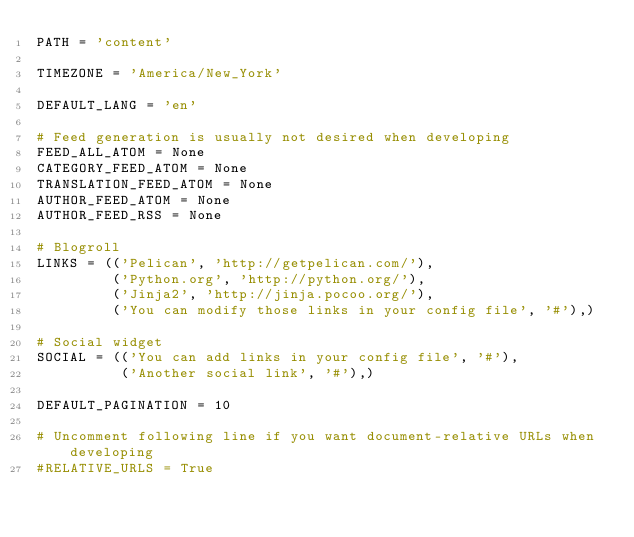Convert code to text. <code><loc_0><loc_0><loc_500><loc_500><_Python_>PATH = 'content'

TIMEZONE = 'America/New_York'

DEFAULT_LANG = 'en'

# Feed generation is usually not desired when developing
FEED_ALL_ATOM = None
CATEGORY_FEED_ATOM = None
TRANSLATION_FEED_ATOM = None
AUTHOR_FEED_ATOM = None
AUTHOR_FEED_RSS = None

# Blogroll
LINKS = (('Pelican', 'http://getpelican.com/'),
         ('Python.org', 'http://python.org/'),
         ('Jinja2', 'http://jinja.pocoo.org/'),
         ('You can modify those links in your config file', '#'),)

# Social widget
SOCIAL = (('You can add links in your config file', '#'),
          ('Another social link', '#'),)

DEFAULT_PAGINATION = 10

# Uncomment following line if you want document-relative URLs when developing
#RELATIVE_URLS = True</code> 